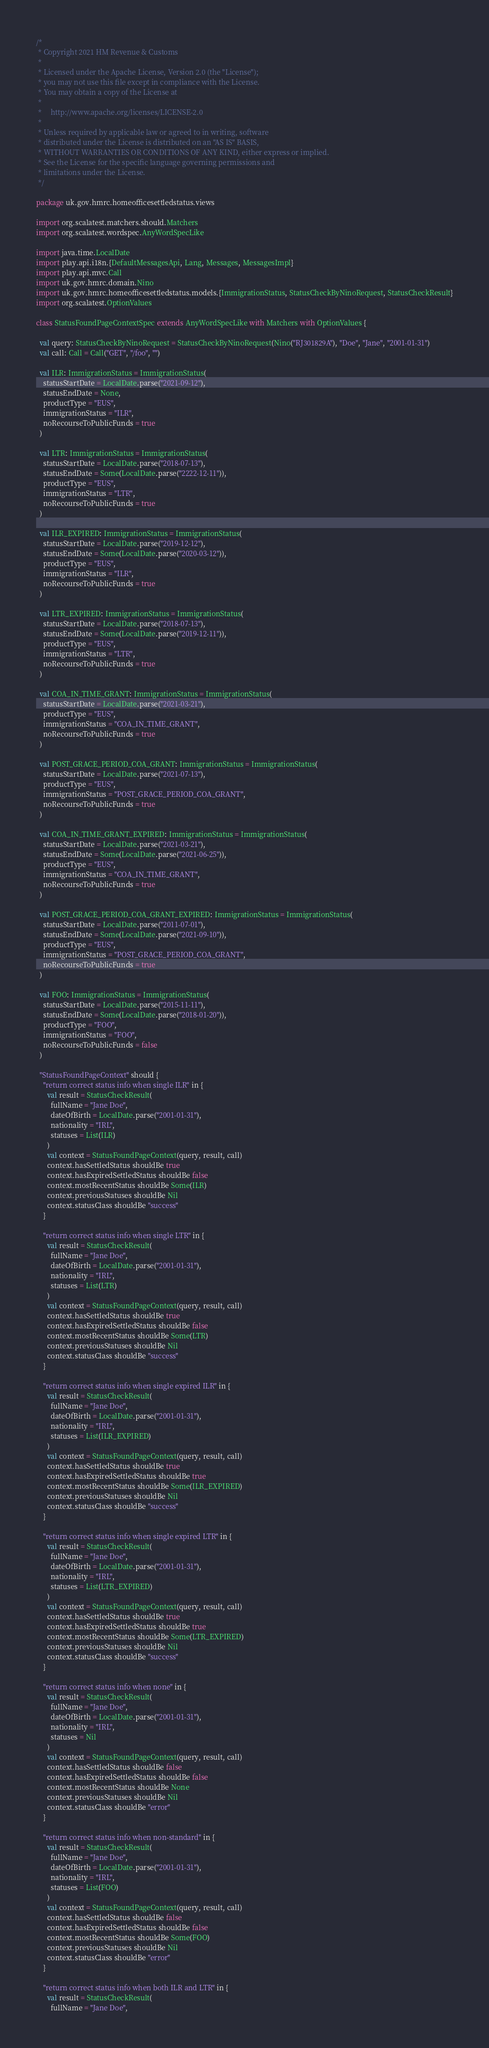<code> <loc_0><loc_0><loc_500><loc_500><_Scala_>/*
 * Copyright 2021 HM Revenue & Customs
 *
 * Licensed under the Apache License, Version 2.0 (the "License");
 * you may not use this file except in compliance with the License.
 * You may obtain a copy of the License at
 *
 *     http://www.apache.org/licenses/LICENSE-2.0
 *
 * Unless required by applicable law or agreed to in writing, software
 * distributed under the License is distributed on an "AS IS" BASIS,
 * WITHOUT WARRANTIES OR CONDITIONS OF ANY KIND, either express or implied.
 * See the License for the specific language governing permissions and
 * limitations under the License.
 */

package uk.gov.hmrc.homeofficesettledstatus.views

import org.scalatest.matchers.should.Matchers
import org.scalatest.wordspec.AnyWordSpecLike

import java.time.LocalDate
import play.api.i18n.{DefaultMessagesApi, Lang, Messages, MessagesImpl}
import play.api.mvc.Call
import uk.gov.hmrc.domain.Nino
import uk.gov.hmrc.homeofficesettledstatus.models.{ImmigrationStatus, StatusCheckByNinoRequest, StatusCheckResult}
import org.scalatest.OptionValues

class StatusFoundPageContextSpec extends AnyWordSpecLike with Matchers with OptionValues {

  val query: StatusCheckByNinoRequest = StatusCheckByNinoRequest(Nino("RJ301829A"), "Doe", "Jane", "2001-01-31")
  val call: Call = Call("GET", "/foo", "")

  val ILR: ImmigrationStatus = ImmigrationStatus(
    statusStartDate = LocalDate.parse("2021-09-12"),
    statusEndDate = None,
    productType = "EUS",
    immigrationStatus = "ILR",
    noRecourseToPublicFunds = true
  )

  val LTR: ImmigrationStatus = ImmigrationStatus(
    statusStartDate = LocalDate.parse("2018-07-13"),
    statusEndDate = Some(LocalDate.parse("2222-12-11")),
    productType = "EUS",
    immigrationStatus = "LTR",
    noRecourseToPublicFunds = true
  )

  val ILR_EXPIRED: ImmigrationStatus = ImmigrationStatus(
    statusStartDate = LocalDate.parse("2019-12-12"),
    statusEndDate = Some(LocalDate.parse("2020-03-12")),
    productType = "EUS",
    immigrationStatus = "ILR",
    noRecourseToPublicFunds = true
  )

  val LTR_EXPIRED: ImmigrationStatus = ImmigrationStatus(
    statusStartDate = LocalDate.parse("2018-07-13"),
    statusEndDate = Some(LocalDate.parse("2019-12-11")),
    productType = "EUS",
    immigrationStatus = "LTR",
    noRecourseToPublicFunds = true
  )

  val COA_IN_TIME_GRANT: ImmigrationStatus = ImmigrationStatus(
    statusStartDate = LocalDate.parse("2021-03-21"),
    productType = "EUS",
    immigrationStatus = "COA_IN_TIME_GRANT",
    noRecourseToPublicFunds = true
  )

  val POST_GRACE_PERIOD_COA_GRANT: ImmigrationStatus = ImmigrationStatus(
    statusStartDate = LocalDate.parse("2021-07-13"),
    productType = "EUS",
    immigrationStatus = "POST_GRACE_PERIOD_COA_GRANT",
    noRecourseToPublicFunds = true
  )

  val COA_IN_TIME_GRANT_EXPIRED: ImmigrationStatus = ImmigrationStatus(
    statusStartDate = LocalDate.parse("2021-03-21"),
    statusEndDate = Some(LocalDate.parse("2021-06-25")),
    productType = "EUS",
    immigrationStatus = "COA_IN_TIME_GRANT",
    noRecourseToPublicFunds = true
  )

  val POST_GRACE_PERIOD_COA_GRANT_EXPIRED: ImmigrationStatus = ImmigrationStatus(
    statusStartDate = LocalDate.parse("2011-07-01"),
    statusEndDate = Some(LocalDate.parse("2021-09-10")),
    productType = "EUS",
    immigrationStatus = "POST_GRACE_PERIOD_COA_GRANT",
    noRecourseToPublicFunds = true
  )

  val FOO: ImmigrationStatus = ImmigrationStatus(
    statusStartDate = LocalDate.parse("2015-11-11"),
    statusEndDate = Some(LocalDate.parse("2018-01-20")),
    productType = "FOO",
    immigrationStatus = "FOO",
    noRecourseToPublicFunds = false
  )

  "StatusFoundPageContext" should {
    "return correct status info when single ILR" in {
      val result = StatusCheckResult(
        fullName = "Jane Doe",
        dateOfBirth = LocalDate.parse("2001-01-31"),
        nationality = "IRL",
        statuses = List(ILR)
      )
      val context = StatusFoundPageContext(query, result, call)
      context.hasSettledStatus shouldBe true
      context.hasExpiredSettledStatus shouldBe false
      context.mostRecentStatus shouldBe Some(ILR)
      context.previousStatuses shouldBe Nil
      context.statusClass shouldBe "success"
    }

    "return correct status info when single LTR" in {
      val result = StatusCheckResult(
        fullName = "Jane Doe",
        dateOfBirth = LocalDate.parse("2001-01-31"),
        nationality = "IRL",
        statuses = List(LTR)
      )
      val context = StatusFoundPageContext(query, result, call)
      context.hasSettledStatus shouldBe true
      context.hasExpiredSettledStatus shouldBe false
      context.mostRecentStatus shouldBe Some(LTR)
      context.previousStatuses shouldBe Nil
      context.statusClass shouldBe "success"
    }

    "return correct status info when single expired ILR" in {
      val result = StatusCheckResult(
        fullName = "Jane Doe",
        dateOfBirth = LocalDate.parse("2001-01-31"),
        nationality = "IRL",
        statuses = List(ILR_EXPIRED)
      )
      val context = StatusFoundPageContext(query, result, call)
      context.hasSettledStatus shouldBe true
      context.hasExpiredSettledStatus shouldBe true
      context.mostRecentStatus shouldBe Some(ILR_EXPIRED)
      context.previousStatuses shouldBe Nil
      context.statusClass shouldBe "success"
    }

    "return correct status info when single expired LTR" in {
      val result = StatusCheckResult(
        fullName = "Jane Doe",
        dateOfBirth = LocalDate.parse("2001-01-31"),
        nationality = "IRL",
        statuses = List(LTR_EXPIRED)
      )
      val context = StatusFoundPageContext(query, result, call)
      context.hasSettledStatus shouldBe true
      context.hasExpiredSettledStatus shouldBe true
      context.mostRecentStatus shouldBe Some(LTR_EXPIRED)
      context.previousStatuses shouldBe Nil
      context.statusClass shouldBe "success"
    }

    "return correct status info when none" in {
      val result = StatusCheckResult(
        fullName = "Jane Doe",
        dateOfBirth = LocalDate.parse("2001-01-31"),
        nationality = "IRL",
        statuses = Nil
      )
      val context = StatusFoundPageContext(query, result, call)
      context.hasSettledStatus shouldBe false
      context.hasExpiredSettledStatus shouldBe false
      context.mostRecentStatus shouldBe None
      context.previousStatuses shouldBe Nil
      context.statusClass shouldBe "error"
    }

    "return correct status info when non-standard" in {
      val result = StatusCheckResult(
        fullName = "Jane Doe",
        dateOfBirth = LocalDate.parse("2001-01-31"),
        nationality = "IRL",
        statuses = List(FOO)
      )
      val context = StatusFoundPageContext(query, result, call)
      context.hasSettledStatus shouldBe false
      context.hasExpiredSettledStatus shouldBe false
      context.mostRecentStatus shouldBe Some(FOO)
      context.previousStatuses shouldBe Nil
      context.statusClass shouldBe "error"
    }

    "return correct status info when both ILR and LTR" in {
      val result = StatusCheckResult(
        fullName = "Jane Doe",</code> 